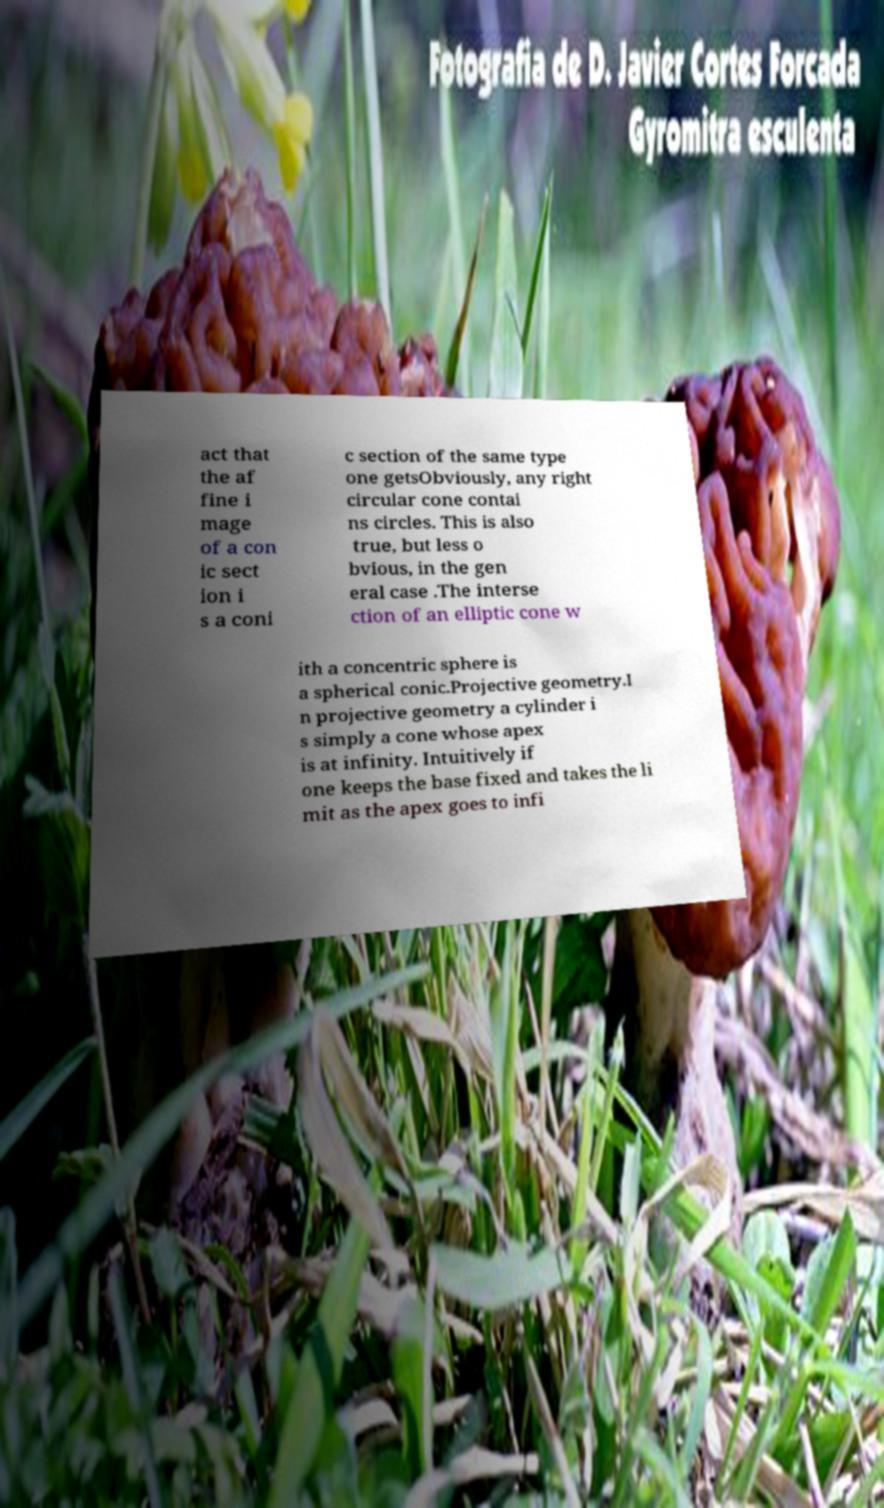What messages or text are displayed in this image? I need them in a readable, typed format. act that the af fine i mage of a con ic sect ion i s a coni c section of the same type one getsObviously, any right circular cone contai ns circles. This is also true, but less o bvious, in the gen eral case .The interse ction of an elliptic cone w ith a concentric sphere is a spherical conic.Projective geometry.I n projective geometry a cylinder i s simply a cone whose apex is at infinity. Intuitively if one keeps the base fixed and takes the li mit as the apex goes to infi 